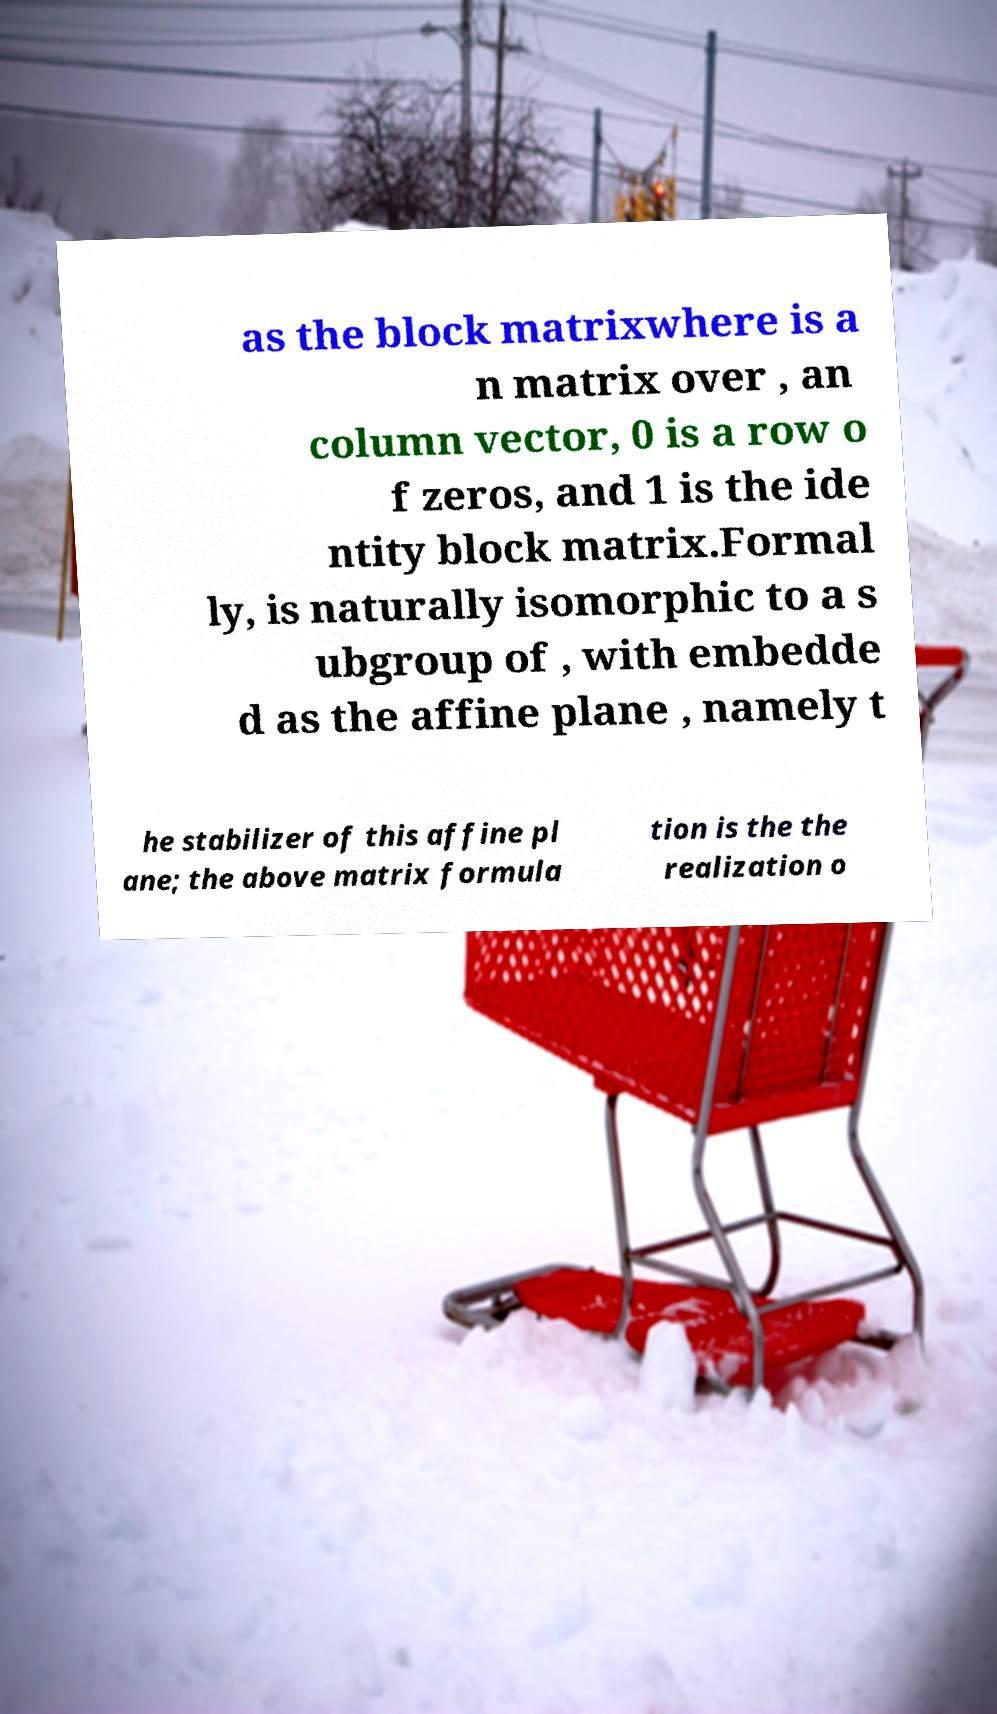Could you assist in decoding the text presented in this image and type it out clearly? as the block matrixwhere is a n matrix over , an column vector, 0 is a row o f zeros, and 1 is the ide ntity block matrix.Formal ly, is naturally isomorphic to a s ubgroup of , with embedde d as the affine plane , namely t he stabilizer of this affine pl ane; the above matrix formula tion is the the realization o 